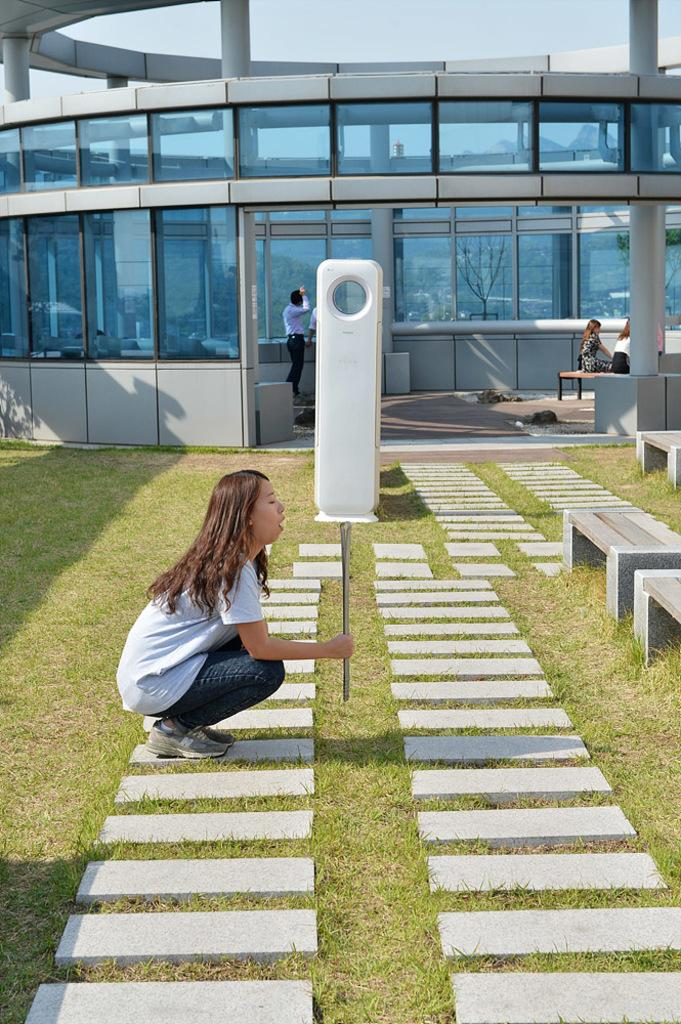Who is the main subject in the image? There is a woman in the image. What is the woman holding in the image? The woman is holding something, but the facts do not specify what it is. What can be seen in the background of the image? There are people in the background of the image. Where are the people located in the image? The people are standing and sitting in an office building. What type of soda is the woman drinking in the image? There is no soda present in the image. What is the woman adjusting on the canvas in the image? There is no canvas or adjustment mentioned in the image. 